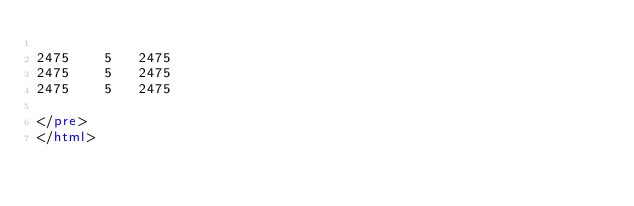Convert code to text. <code><loc_0><loc_0><loc_500><loc_500><_HTML_>
2475	5	2475
2475	5	2475
2475	5	2475

</pre>
</html>
</code> 